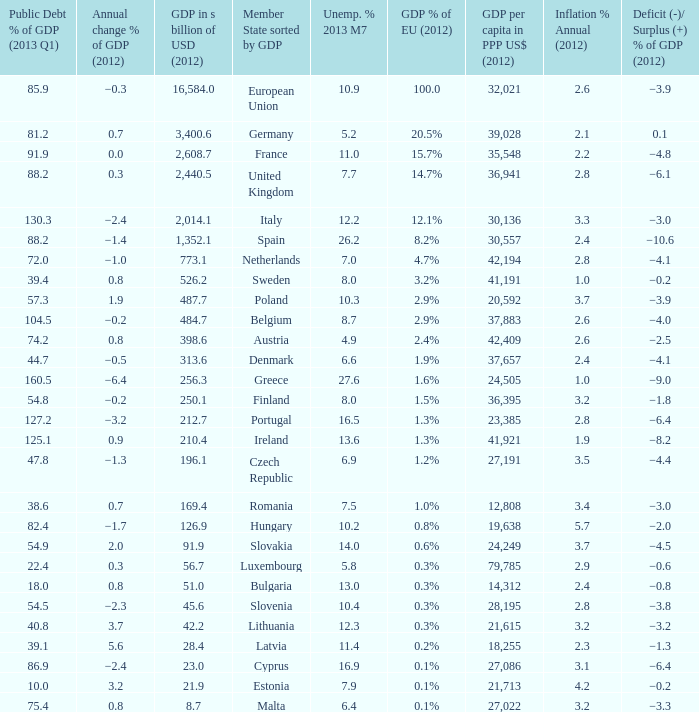What is the greatest annual inflation rate in 2012 for the country with a public debt ratio of gdp in 2013 q1 above 8 2.6. 